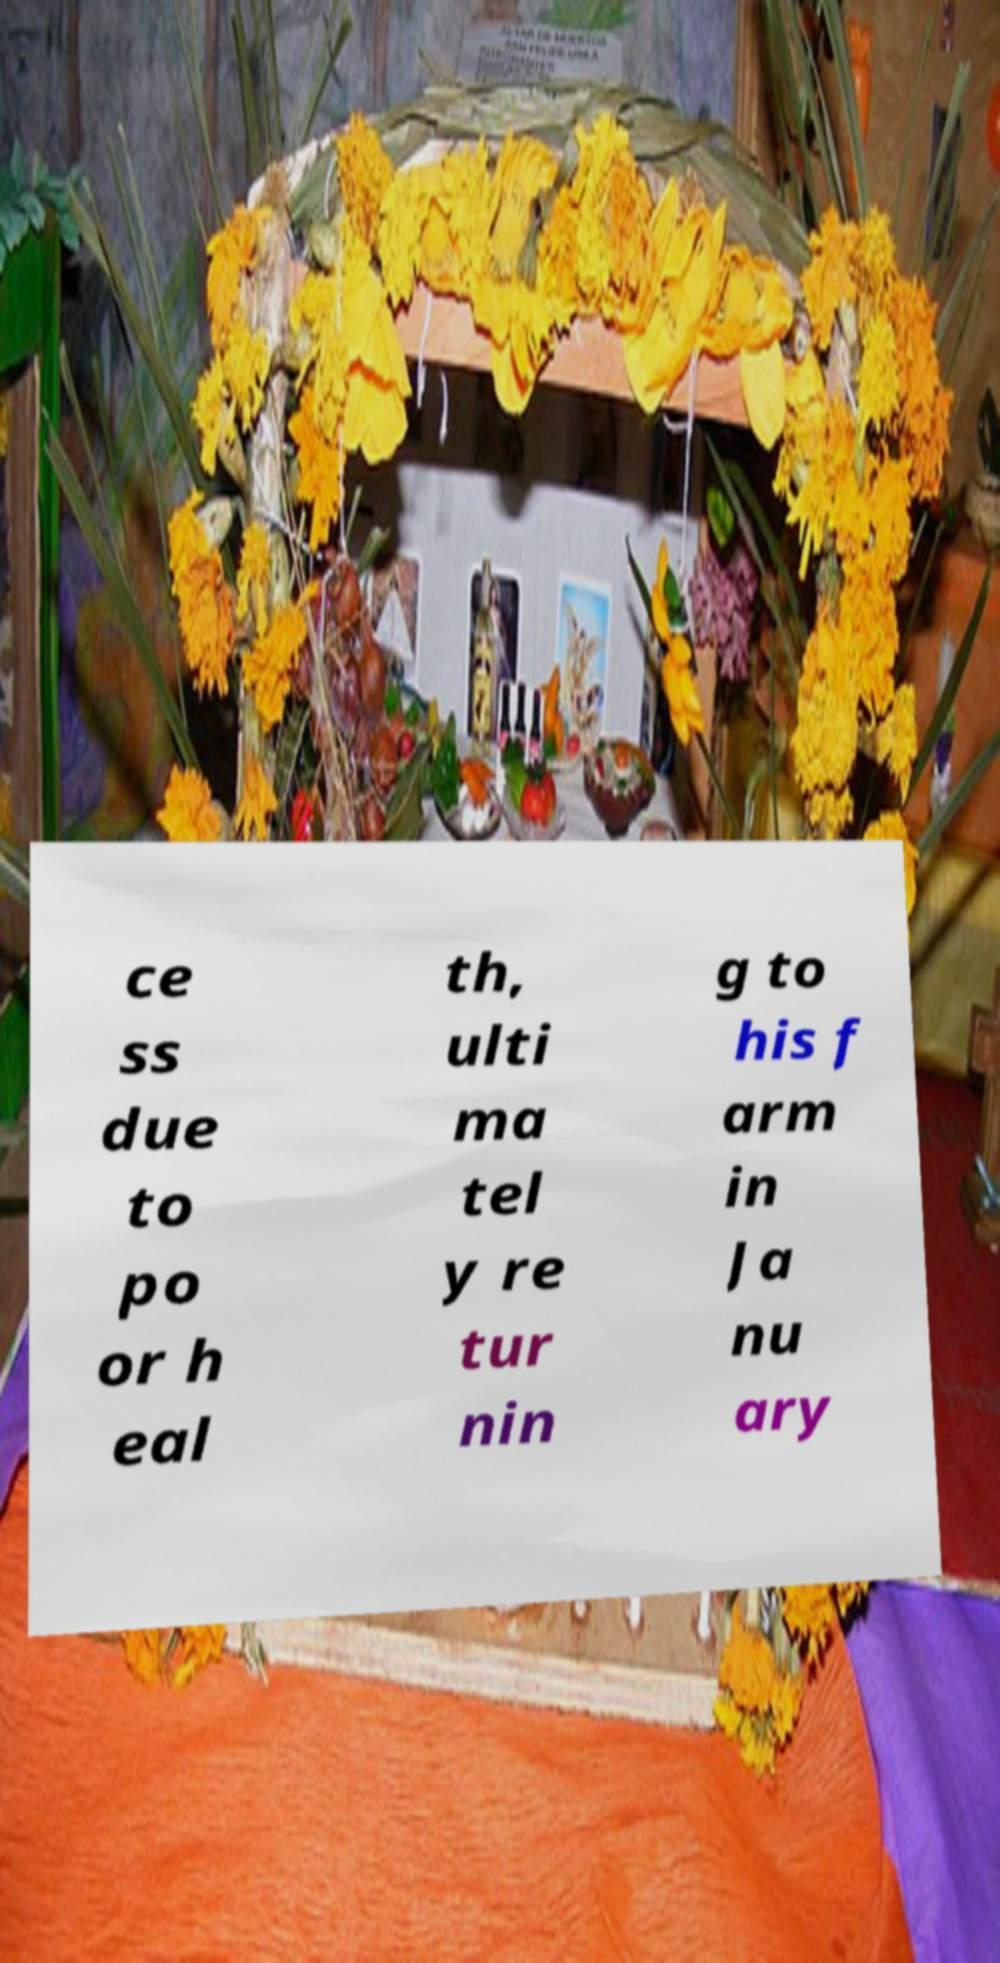For documentation purposes, I need the text within this image transcribed. Could you provide that? ce ss due to po or h eal th, ulti ma tel y re tur nin g to his f arm in Ja nu ary 